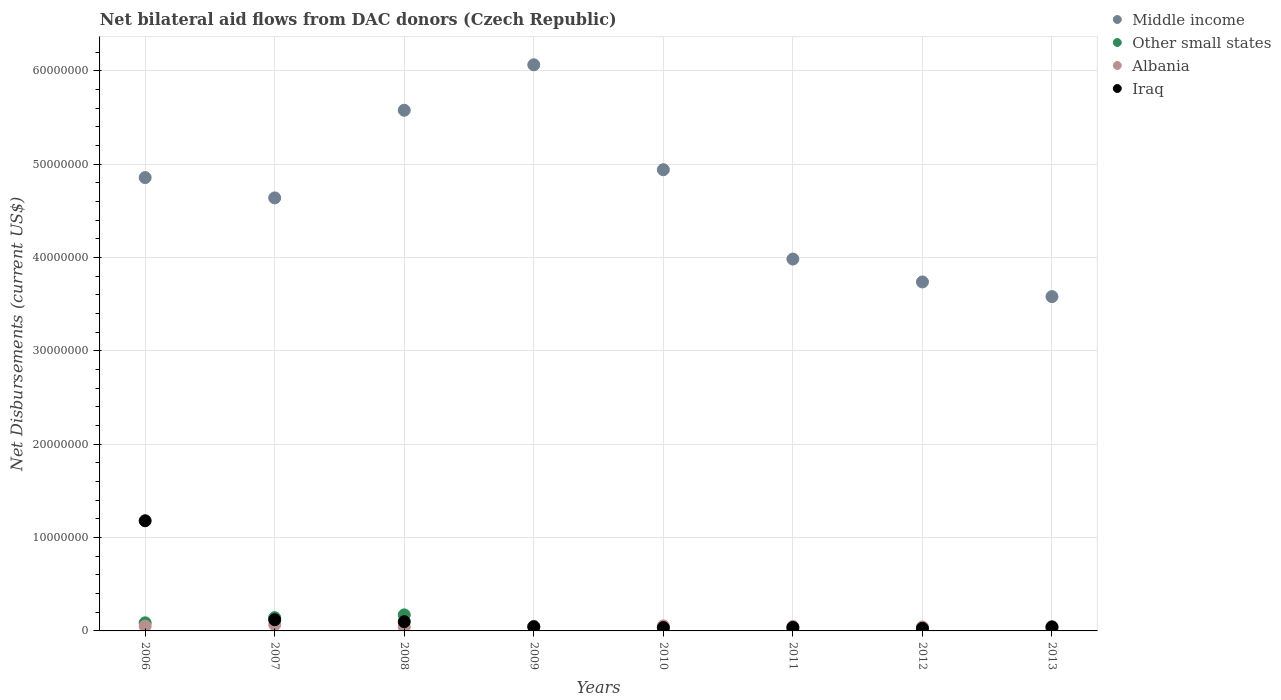How many different coloured dotlines are there?
Give a very brief answer. 4. Is the number of dotlines equal to the number of legend labels?
Give a very brief answer. Yes. What is the net bilateral aid flows in Albania in 2010?
Provide a short and direct response. 5.40e+05. Across all years, what is the maximum net bilateral aid flows in Albania?
Provide a short and direct response. 6.80e+05. Across all years, what is the minimum net bilateral aid flows in Middle income?
Provide a short and direct response. 3.58e+07. What is the total net bilateral aid flows in Albania in the graph?
Give a very brief answer. 3.72e+06. What is the difference between the net bilateral aid flows in Middle income in 2011 and that in 2013?
Your answer should be compact. 4.02e+06. What is the difference between the net bilateral aid flows in Other small states in 2013 and the net bilateral aid flows in Iraq in 2008?
Keep it short and to the point. -6.10e+05. What is the average net bilateral aid flows in Other small states per year?
Offer a very short reply. 7.18e+05. In the year 2006, what is the difference between the net bilateral aid flows in Other small states and net bilateral aid flows in Albania?
Your answer should be compact. 3.60e+05. In how many years, is the net bilateral aid flows in Albania greater than 20000000 US$?
Your answer should be very brief. 0. What is the ratio of the net bilateral aid flows in Albania in 2006 to that in 2011?
Offer a very short reply. 1.09. Is the net bilateral aid flows in Middle income in 2006 less than that in 2008?
Offer a very short reply. Yes. What is the difference between the highest and the second highest net bilateral aid flows in Albania?
Your answer should be very brief. 1.40e+05. What is the difference between the highest and the lowest net bilateral aid flows in Other small states?
Provide a short and direct response. 1.49e+06. Is the net bilateral aid flows in Middle income strictly less than the net bilateral aid flows in Other small states over the years?
Your response must be concise. No. How many years are there in the graph?
Give a very brief answer. 8. What is the difference between two consecutive major ticks on the Y-axis?
Make the answer very short. 1.00e+07. Does the graph contain any zero values?
Your answer should be compact. No. Where does the legend appear in the graph?
Provide a succinct answer. Top right. How are the legend labels stacked?
Offer a terse response. Vertical. What is the title of the graph?
Ensure brevity in your answer.  Net bilateral aid flows from DAC donors (Czech Republic). Does "Vietnam" appear as one of the legend labels in the graph?
Your answer should be very brief. No. What is the label or title of the Y-axis?
Offer a terse response. Net Disbursements (current US$). What is the Net Disbursements (current US$) of Middle income in 2006?
Provide a succinct answer. 4.86e+07. What is the Net Disbursements (current US$) in Other small states in 2006?
Provide a succinct answer. 8.70e+05. What is the Net Disbursements (current US$) of Albania in 2006?
Provide a short and direct response. 5.10e+05. What is the Net Disbursements (current US$) in Iraq in 2006?
Your response must be concise. 1.18e+07. What is the Net Disbursements (current US$) in Middle income in 2007?
Ensure brevity in your answer.  4.64e+07. What is the Net Disbursements (current US$) of Other small states in 2007?
Offer a terse response. 1.42e+06. What is the Net Disbursements (current US$) of Albania in 2007?
Ensure brevity in your answer.  6.80e+05. What is the Net Disbursements (current US$) in Iraq in 2007?
Offer a terse response. 1.20e+06. What is the Net Disbursements (current US$) in Middle income in 2008?
Keep it short and to the point. 5.58e+07. What is the Net Disbursements (current US$) of Other small states in 2008?
Ensure brevity in your answer.  1.72e+06. What is the Net Disbursements (current US$) of Albania in 2008?
Provide a short and direct response. 4.20e+05. What is the Net Disbursements (current US$) of Iraq in 2008?
Your answer should be compact. 9.90e+05. What is the Net Disbursements (current US$) in Middle income in 2009?
Provide a succinct answer. 6.06e+07. What is the Net Disbursements (current US$) in Other small states in 2009?
Offer a terse response. 4.90e+05. What is the Net Disbursements (current US$) in Albania in 2009?
Offer a very short reply. 4.60e+05. What is the Net Disbursements (current US$) of Middle income in 2010?
Ensure brevity in your answer.  4.94e+07. What is the Net Disbursements (current US$) of Other small states in 2010?
Offer a terse response. 3.70e+05. What is the Net Disbursements (current US$) in Albania in 2010?
Your answer should be very brief. 5.40e+05. What is the Net Disbursements (current US$) of Iraq in 2010?
Offer a very short reply. 3.60e+05. What is the Net Disbursements (current US$) of Middle income in 2011?
Your answer should be compact. 3.98e+07. What is the Net Disbursements (current US$) of Other small states in 2011?
Offer a very short reply. 2.30e+05. What is the Net Disbursements (current US$) in Albania in 2011?
Provide a succinct answer. 4.70e+05. What is the Net Disbursements (current US$) of Middle income in 2012?
Give a very brief answer. 3.74e+07. What is the Net Disbursements (current US$) in Other small states in 2012?
Offer a terse response. 2.60e+05. What is the Net Disbursements (current US$) of Albania in 2012?
Provide a succinct answer. 4.20e+05. What is the Net Disbursements (current US$) of Iraq in 2012?
Keep it short and to the point. 2.80e+05. What is the Net Disbursements (current US$) of Middle income in 2013?
Give a very brief answer. 3.58e+07. What is the Net Disbursements (current US$) in Albania in 2013?
Give a very brief answer. 2.20e+05. Across all years, what is the maximum Net Disbursements (current US$) of Middle income?
Keep it short and to the point. 6.06e+07. Across all years, what is the maximum Net Disbursements (current US$) in Other small states?
Make the answer very short. 1.72e+06. Across all years, what is the maximum Net Disbursements (current US$) of Albania?
Make the answer very short. 6.80e+05. Across all years, what is the maximum Net Disbursements (current US$) of Iraq?
Your response must be concise. 1.18e+07. Across all years, what is the minimum Net Disbursements (current US$) of Middle income?
Give a very brief answer. 3.58e+07. What is the total Net Disbursements (current US$) in Middle income in the graph?
Provide a short and direct response. 3.74e+08. What is the total Net Disbursements (current US$) in Other small states in the graph?
Offer a very short reply. 5.74e+06. What is the total Net Disbursements (current US$) in Albania in the graph?
Your answer should be very brief. 3.72e+06. What is the total Net Disbursements (current US$) in Iraq in the graph?
Ensure brevity in your answer.  1.59e+07. What is the difference between the Net Disbursements (current US$) in Middle income in 2006 and that in 2007?
Offer a terse response. 2.18e+06. What is the difference between the Net Disbursements (current US$) in Other small states in 2006 and that in 2007?
Provide a succinct answer. -5.50e+05. What is the difference between the Net Disbursements (current US$) in Iraq in 2006 and that in 2007?
Give a very brief answer. 1.06e+07. What is the difference between the Net Disbursements (current US$) of Middle income in 2006 and that in 2008?
Your response must be concise. -7.21e+06. What is the difference between the Net Disbursements (current US$) in Other small states in 2006 and that in 2008?
Provide a succinct answer. -8.50e+05. What is the difference between the Net Disbursements (current US$) in Iraq in 2006 and that in 2008?
Make the answer very short. 1.08e+07. What is the difference between the Net Disbursements (current US$) of Middle income in 2006 and that in 2009?
Ensure brevity in your answer.  -1.21e+07. What is the difference between the Net Disbursements (current US$) in Albania in 2006 and that in 2009?
Offer a terse response. 5.00e+04. What is the difference between the Net Disbursements (current US$) of Iraq in 2006 and that in 2009?
Provide a succinct answer. 1.14e+07. What is the difference between the Net Disbursements (current US$) of Middle income in 2006 and that in 2010?
Your response must be concise. -8.40e+05. What is the difference between the Net Disbursements (current US$) in Other small states in 2006 and that in 2010?
Keep it short and to the point. 5.00e+05. What is the difference between the Net Disbursements (current US$) of Albania in 2006 and that in 2010?
Offer a very short reply. -3.00e+04. What is the difference between the Net Disbursements (current US$) of Iraq in 2006 and that in 2010?
Provide a short and direct response. 1.14e+07. What is the difference between the Net Disbursements (current US$) of Middle income in 2006 and that in 2011?
Keep it short and to the point. 8.73e+06. What is the difference between the Net Disbursements (current US$) in Other small states in 2006 and that in 2011?
Provide a short and direct response. 6.40e+05. What is the difference between the Net Disbursements (current US$) in Albania in 2006 and that in 2011?
Give a very brief answer. 4.00e+04. What is the difference between the Net Disbursements (current US$) of Iraq in 2006 and that in 2011?
Offer a terse response. 1.14e+07. What is the difference between the Net Disbursements (current US$) in Middle income in 2006 and that in 2012?
Keep it short and to the point. 1.12e+07. What is the difference between the Net Disbursements (current US$) in Albania in 2006 and that in 2012?
Keep it short and to the point. 9.00e+04. What is the difference between the Net Disbursements (current US$) in Iraq in 2006 and that in 2012?
Offer a very short reply. 1.15e+07. What is the difference between the Net Disbursements (current US$) of Middle income in 2006 and that in 2013?
Provide a short and direct response. 1.28e+07. What is the difference between the Net Disbursements (current US$) in Iraq in 2006 and that in 2013?
Offer a terse response. 1.14e+07. What is the difference between the Net Disbursements (current US$) of Middle income in 2007 and that in 2008?
Your response must be concise. -9.39e+06. What is the difference between the Net Disbursements (current US$) of Other small states in 2007 and that in 2008?
Provide a short and direct response. -3.00e+05. What is the difference between the Net Disbursements (current US$) of Middle income in 2007 and that in 2009?
Offer a terse response. -1.43e+07. What is the difference between the Net Disbursements (current US$) of Other small states in 2007 and that in 2009?
Your answer should be very brief. 9.30e+05. What is the difference between the Net Disbursements (current US$) of Albania in 2007 and that in 2009?
Make the answer very short. 2.20e+05. What is the difference between the Net Disbursements (current US$) of Iraq in 2007 and that in 2009?
Ensure brevity in your answer.  7.60e+05. What is the difference between the Net Disbursements (current US$) of Middle income in 2007 and that in 2010?
Your response must be concise. -3.02e+06. What is the difference between the Net Disbursements (current US$) in Other small states in 2007 and that in 2010?
Give a very brief answer. 1.05e+06. What is the difference between the Net Disbursements (current US$) of Albania in 2007 and that in 2010?
Provide a succinct answer. 1.40e+05. What is the difference between the Net Disbursements (current US$) in Iraq in 2007 and that in 2010?
Provide a succinct answer. 8.40e+05. What is the difference between the Net Disbursements (current US$) in Middle income in 2007 and that in 2011?
Keep it short and to the point. 6.55e+06. What is the difference between the Net Disbursements (current US$) of Other small states in 2007 and that in 2011?
Your response must be concise. 1.19e+06. What is the difference between the Net Disbursements (current US$) in Iraq in 2007 and that in 2011?
Give a very brief answer. 8.20e+05. What is the difference between the Net Disbursements (current US$) of Middle income in 2007 and that in 2012?
Your answer should be compact. 9.00e+06. What is the difference between the Net Disbursements (current US$) of Other small states in 2007 and that in 2012?
Make the answer very short. 1.16e+06. What is the difference between the Net Disbursements (current US$) of Iraq in 2007 and that in 2012?
Your answer should be very brief. 9.20e+05. What is the difference between the Net Disbursements (current US$) of Middle income in 2007 and that in 2013?
Offer a very short reply. 1.06e+07. What is the difference between the Net Disbursements (current US$) in Other small states in 2007 and that in 2013?
Ensure brevity in your answer.  1.04e+06. What is the difference between the Net Disbursements (current US$) in Albania in 2007 and that in 2013?
Provide a succinct answer. 4.60e+05. What is the difference between the Net Disbursements (current US$) in Iraq in 2007 and that in 2013?
Offer a terse response. 7.60e+05. What is the difference between the Net Disbursements (current US$) of Middle income in 2008 and that in 2009?
Offer a very short reply. -4.87e+06. What is the difference between the Net Disbursements (current US$) in Other small states in 2008 and that in 2009?
Your answer should be compact. 1.23e+06. What is the difference between the Net Disbursements (current US$) of Iraq in 2008 and that in 2009?
Your answer should be very brief. 5.50e+05. What is the difference between the Net Disbursements (current US$) in Middle income in 2008 and that in 2010?
Provide a succinct answer. 6.37e+06. What is the difference between the Net Disbursements (current US$) of Other small states in 2008 and that in 2010?
Give a very brief answer. 1.35e+06. What is the difference between the Net Disbursements (current US$) in Albania in 2008 and that in 2010?
Offer a terse response. -1.20e+05. What is the difference between the Net Disbursements (current US$) in Iraq in 2008 and that in 2010?
Offer a very short reply. 6.30e+05. What is the difference between the Net Disbursements (current US$) of Middle income in 2008 and that in 2011?
Your answer should be very brief. 1.59e+07. What is the difference between the Net Disbursements (current US$) in Other small states in 2008 and that in 2011?
Your answer should be compact. 1.49e+06. What is the difference between the Net Disbursements (current US$) of Middle income in 2008 and that in 2012?
Offer a terse response. 1.84e+07. What is the difference between the Net Disbursements (current US$) of Other small states in 2008 and that in 2012?
Provide a succinct answer. 1.46e+06. What is the difference between the Net Disbursements (current US$) in Albania in 2008 and that in 2012?
Your response must be concise. 0. What is the difference between the Net Disbursements (current US$) of Iraq in 2008 and that in 2012?
Keep it short and to the point. 7.10e+05. What is the difference between the Net Disbursements (current US$) in Middle income in 2008 and that in 2013?
Provide a succinct answer. 2.00e+07. What is the difference between the Net Disbursements (current US$) of Other small states in 2008 and that in 2013?
Your answer should be compact. 1.34e+06. What is the difference between the Net Disbursements (current US$) in Middle income in 2009 and that in 2010?
Provide a succinct answer. 1.12e+07. What is the difference between the Net Disbursements (current US$) of Other small states in 2009 and that in 2010?
Offer a terse response. 1.20e+05. What is the difference between the Net Disbursements (current US$) of Iraq in 2009 and that in 2010?
Offer a very short reply. 8.00e+04. What is the difference between the Net Disbursements (current US$) of Middle income in 2009 and that in 2011?
Offer a terse response. 2.08e+07. What is the difference between the Net Disbursements (current US$) of Iraq in 2009 and that in 2011?
Make the answer very short. 6.00e+04. What is the difference between the Net Disbursements (current US$) in Middle income in 2009 and that in 2012?
Offer a very short reply. 2.33e+07. What is the difference between the Net Disbursements (current US$) of Other small states in 2009 and that in 2012?
Make the answer very short. 2.30e+05. What is the difference between the Net Disbursements (current US$) of Albania in 2009 and that in 2012?
Give a very brief answer. 4.00e+04. What is the difference between the Net Disbursements (current US$) of Iraq in 2009 and that in 2012?
Provide a succinct answer. 1.60e+05. What is the difference between the Net Disbursements (current US$) of Middle income in 2009 and that in 2013?
Provide a succinct answer. 2.48e+07. What is the difference between the Net Disbursements (current US$) in Albania in 2009 and that in 2013?
Keep it short and to the point. 2.40e+05. What is the difference between the Net Disbursements (current US$) in Middle income in 2010 and that in 2011?
Ensure brevity in your answer.  9.57e+06. What is the difference between the Net Disbursements (current US$) of Albania in 2010 and that in 2011?
Your response must be concise. 7.00e+04. What is the difference between the Net Disbursements (current US$) in Middle income in 2010 and that in 2012?
Your response must be concise. 1.20e+07. What is the difference between the Net Disbursements (current US$) in Albania in 2010 and that in 2012?
Give a very brief answer. 1.20e+05. What is the difference between the Net Disbursements (current US$) of Middle income in 2010 and that in 2013?
Offer a terse response. 1.36e+07. What is the difference between the Net Disbursements (current US$) in Other small states in 2010 and that in 2013?
Make the answer very short. -10000. What is the difference between the Net Disbursements (current US$) of Albania in 2010 and that in 2013?
Your answer should be very brief. 3.20e+05. What is the difference between the Net Disbursements (current US$) in Iraq in 2010 and that in 2013?
Offer a very short reply. -8.00e+04. What is the difference between the Net Disbursements (current US$) in Middle income in 2011 and that in 2012?
Your answer should be very brief. 2.45e+06. What is the difference between the Net Disbursements (current US$) of Albania in 2011 and that in 2012?
Your answer should be compact. 5.00e+04. What is the difference between the Net Disbursements (current US$) in Iraq in 2011 and that in 2012?
Ensure brevity in your answer.  1.00e+05. What is the difference between the Net Disbursements (current US$) of Middle income in 2011 and that in 2013?
Your answer should be very brief. 4.02e+06. What is the difference between the Net Disbursements (current US$) in Albania in 2011 and that in 2013?
Provide a succinct answer. 2.50e+05. What is the difference between the Net Disbursements (current US$) of Middle income in 2012 and that in 2013?
Ensure brevity in your answer.  1.57e+06. What is the difference between the Net Disbursements (current US$) of Other small states in 2012 and that in 2013?
Your response must be concise. -1.20e+05. What is the difference between the Net Disbursements (current US$) in Iraq in 2012 and that in 2013?
Offer a very short reply. -1.60e+05. What is the difference between the Net Disbursements (current US$) of Middle income in 2006 and the Net Disbursements (current US$) of Other small states in 2007?
Make the answer very short. 4.71e+07. What is the difference between the Net Disbursements (current US$) in Middle income in 2006 and the Net Disbursements (current US$) in Albania in 2007?
Make the answer very short. 4.79e+07. What is the difference between the Net Disbursements (current US$) of Middle income in 2006 and the Net Disbursements (current US$) of Iraq in 2007?
Provide a short and direct response. 4.74e+07. What is the difference between the Net Disbursements (current US$) of Other small states in 2006 and the Net Disbursements (current US$) of Albania in 2007?
Your answer should be compact. 1.90e+05. What is the difference between the Net Disbursements (current US$) of Other small states in 2006 and the Net Disbursements (current US$) of Iraq in 2007?
Give a very brief answer. -3.30e+05. What is the difference between the Net Disbursements (current US$) in Albania in 2006 and the Net Disbursements (current US$) in Iraq in 2007?
Keep it short and to the point. -6.90e+05. What is the difference between the Net Disbursements (current US$) of Middle income in 2006 and the Net Disbursements (current US$) of Other small states in 2008?
Give a very brief answer. 4.68e+07. What is the difference between the Net Disbursements (current US$) of Middle income in 2006 and the Net Disbursements (current US$) of Albania in 2008?
Offer a terse response. 4.81e+07. What is the difference between the Net Disbursements (current US$) in Middle income in 2006 and the Net Disbursements (current US$) in Iraq in 2008?
Offer a very short reply. 4.76e+07. What is the difference between the Net Disbursements (current US$) in Other small states in 2006 and the Net Disbursements (current US$) in Albania in 2008?
Your response must be concise. 4.50e+05. What is the difference between the Net Disbursements (current US$) of Other small states in 2006 and the Net Disbursements (current US$) of Iraq in 2008?
Make the answer very short. -1.20e+05. What is the difference between the Net Disbursements (current US$) in Albania in 2006 and the Net Disbursements (current US$) in Iraq in 2008?
Ensure brevity in your answer.  -4.80e+05. What is the difference between the Net Disbursements (current US$) in Middle income in 2006 and the Net Disbursements (current US$) in Other small states in 2009?
Offer a terse response. 4.81e+07. What is the difference between the Net Disbursements (current US$) in Middle income in 2006 and the Net Disbursements (current US$) in Albania in 2009?
Your answer should be compact. 4.81e+07. What is the difference between the Net Disbursements (current US$) of Middle income in 2006 and the Net Disbursements (current US$) of Iraq in 2009?
Offer a very short reply. 4.81e+07. What is the difference between the Net Disbursements (current US$) in Other small states in 2006 and the Net Disbursements (current US$) in Albania in 2009?
Provide a short and direct response. 4.10e+05. What is the difference between the Net Disbursements (current US$) in Middle income in 2006 and the Net Disbursements (current US$) in Other small states in 2010?
Offer a terse response. 4.82e+07. What is the difference between the Net Disbursements (current US$) in Middle income in 2006 and the Net Disbursements (current US$) in Albania in 2010?
Your answer should be compact. 4.80e+07. What is the difference between the Net Disbursements (current US$) in Middle income in 2006 and the Net Disbursements (current US$) in Iraq in 2010?
Offer a very short reply. 4.82e+07. What is the difference between the Net Disbursements (current US$) of Other small states in 2006 and the Net Disbursements (current US$) of Iraq in 2010?
Offer a very short reply. 5.10e+05. What is the difference between the Net Disbursements (current US$) of Albania in 2006 and the Net Disbursements (current US$) of Iraq in 2010?
Your response must be concise. 1.50e+05. What is the difference between the Net Disbursements (current US$) of Middle income in 2006 and the Net Disbursements (current US$) of Other small states in 2011?
Your answer should be very brief. 4.83e+07. What is the difference between the Net Disbursements (current US$) of Middle income in 2006 and the Net Disbursements (current US$) of Albania in 2011?
Give a very brief answer. 4.81e+07. What is the difference between the Net Disbursements (current US$) in Middle income in 2006 and the Net Disbursements (current US$) in Iraq in 2011?
Your answer should be very brief. 4.82e+07. What is the difference between the Net Disbursements (current US$) in Middle income in 2006 and the Net Disbursements (current US$) in Other small states in 2012?
Keep it short and to the point. 4.83e+07. What is the difference between the Net Disbursements (current US$) of Middle income in 2006 and the Net Disbursements (current US$) of Albania in 2012?
Your answer should be compact. 4.81e+07. What is the difference between the Net Disbursements (current US$) in Middle income in 2006 and the Net Disbursements (current US$) in Iraq in 2012?
Offer a very short reply. 4.83e+07. What is the difference between the Net Disbursements (current US$) in Other small states in 2006 and the Net Disbursements (current US$) in Iraq in 2012?
Provide a short and direct response. 5.90e+05. What is the difference between the Net Disbursements (current US$) of Albania in 2006 and the Net Disbursements (current US$) of Iraq in 2012?
Offer a terse response. 2.30e+05. What is the difference between the Net Disbursements (current US$) of Middle income in 2006 and the Net Disbursements (current US$) of Other small states in 2013?
Keep it short and to the point. 4.82e+07. What is the difference between the Net Disbursements (current US$) in Middle income in 2006 and the Net Disbursements (current US$) in Albania in 2013?
Provide a short and direct response. 4.83e+07. What is the difference between the Net Disbursements (current US$) in Middle income in 2006 and the Net Disbursements (current US$) in Iraq in 2013?
Make the answer very short. 4.81e+07. What is the difference between the Net Disbursements (current US$) in Other small states in 2006 and the Net Disbursements (current US$) in Albania in 2013?
Give a very brief answer. 6.50e+05. What is the difference between the Net Disbursements (current US$) in Other small states in 2006 and the Net Disbursements (current US$) in Iraq in 2013?
Your answer should be compact. 4.30e+05. What is the difference between the Net Disbursements (current US$) of Albania in 2006 and the Net Disbursements (current US$) of Iraq in 2013?
Ensure brevity in your answer.  7.00e+04. What is the difference between the Net Disbursements (current US$) of Middle income in 2007 and the Net Disbursements (current US$) of Other small states in 2008?
Offer a very short reply. 4.47e+07. What is the difference between the Net Disbursements (current US$) in Middle income in 2007 and the Net Disbursements (current US$) in Albania in 2008?
Your answer should be compact. 4.60e+07. What is the difference between the Net Disbursements (current US$) in Middle income in 2007 and the Net Disbursements (current US$) in Iraq in 2008?
Ensure brevity in your answer.  4.54e+07. What is the difference between the Net Disbursements (current US$) in Other small states in 2007 and the Net Disbursements (current US$) in Albania in 2008?
Your answer should be compact. 1.00e+06. What is the difference between the Net Disbursements (current US$) of Albania in 2007 and the Net Disbursements (current US$) of Iraq in 2008?
Your answer should be very brief. -3.10e+05. What is the difference between the Net Disbursements (current US$) in Middle income in 2007 and the Net Disbursements (current US$) in Other small states in 2009?
Give a very brief answer. 4.59e+07. What is the difference between the Net Disbursements (current US$) of Middle income in 2007 and the Net Disbursements (current US$) of Albania in 2009?
Give a very brief answer. 4.59e+07. What is the difference between the Net Disbursements (current US$) of Middle income in 2007 and the Net Disbursements (current US$) of Iraq in 2009?
Keep it short and to the point. 4.59e+07. What is the difference between the Net Disbursements (current US$) in Other small states in 2007 and the Net Disbursements (current US$) in Albania in 2009?
Ensure brevity in your answer.  9.60e+05. What is the difference between the Net Disbursements (current US$) of Other small states in 2007 and the Net Disbursements (current US$) of Iraq in 2009?
Your answer should be very brief. 9.80e+05. What is the difference between the Net Disbursements (current US$) of Albania in 2007 and the Net Disbursements (current US$) of Iraq in 2009?
Keep it short and to the point. 2.40e+05. What is the difference between the Net Disbursements (current US$) of Middle income in 2007 and the Net Disbursements (current US$) of Other small states in 2010?
Make the answer very short. 4.60e+07. What is the difference between the Net Disbursements (current US$) in Middle income in 2007 and the Net Disbursements (current US$) in Albania in 2010?
Give a very brief answer. 4.58e+07. What is the difference between the Net Disbursements (current US$) in Middle income in 2007 and the Net Disbursements (current US$) in Iraq in 2010?
Provide a short and direct response. 4.60e+07. What is the difference between the Net Disbursements (current US$) in Other small states in 2007 and the Net Disbursements (current US$) in Albania in 2010?
Offer a very short reply. 8.80e+05. What is the difference between the Net Disbursements (current US$) of Other small states in 2007 and the Net Disbursements (current US$) of Iraq in 2010?
Provide a short and direct response. 1.06e+06. What is the difference between the Net Disbursements (current US$) of Middle income in 2007 and the Net Disbursements (current US$) of Other small states in 2011?
Make the answer very short. 4.62e+07. What is the difference between the Net Disbursements (current US$) in Middle income in 2007 and the Net Disbursements (current US$) in Albania in 2011?
Your response must be concise. 4.59e+07. What is the difference between the Net Disbursements (current US$) in Middle income in 2007 and the Net Disbursements (current US$) in Iraq in 2011?
Keep it short and to the point. 4.60e+07. What is the difference between the Net Disbursements (current US$) of Other small states in 2007 and the Net Disbursements (current US$) of Albania in 2011?
Offer a terse response. 9.50e+05. What is the difference between the Net Disbursements (current US$) in Other small states in 2007 and the Net Disbursements (current US$) in Iraq in 2011?
Make the answer very short. 1.04e+06. What is the difference between the Net Disbursements (current US$) in Albania in 2007 and the Net Disbursements (current US$) in Iraq in 2011?
Your answer should be very brief. 3.00e+05. What is the difference between the Net Disbursements (current US$) in Middle income in 2007 and the Net Disbursements (current US$) in Other small states in 2012?
Keep it short and to the point. 4.61e+07. What is the difference between the Net Disbursements (current US$) of Middle income in 2007 and the Net Disbursements (current US$) of Albania in 2012?
Give a very brief answer. 4.60e+07. What is the difference between the Net Disbursements (current US$) of Middle income in 2007 and the Net Disbursements (current US$) of Iraq in 2012?
Provide a succinct answer. 4.61e+07. What is the difference between the Net Disbursements (current US$) in Other small states in 2007 and the Net Disbursements (current US$) in Iraq in 2012?
Make the answer very short. 1.14e+06. What is the difference between the Net Disbursements (current US$) in Middle income in 2007 and the Net Disbursements (current US$) in Other small states in 2013?
Make the answer very short. 4.60e+07. What is the difference between the Net Disbursements (current US$) in Middle income in 2007 and the Net Disbursements (current US$) in Albania in 2013?
Make the answer very short. 4.62e+07. What is the difference between the Net Disbursements (current US$) in Middle income in 2007 and the Net Disbursements (current US$) in Iraq in 2013?
Provide a succinct answer. 4.59e+07. What is the difference between the Net Disbursements (current US$) in Other small states in 2007 and the Net Disbursements (current US$) in Albania in 2013?
Give a very brief answer. 1.20e+06. What is the difference between the Net Disbursements (current US$) of Other small states in 2007 and the Net Disbursements (current US$) of Iraq in 2013?
Provide a short and direct response. 9.80e+05. What is the difference between the Net Disbursements (current US$) in Albania in 2007 and the Net Disbursements (current US$) in Iraq in 2013?
Give a very brief answer. 2.40e+05. What is the difference between the Net Disbursements (current US$) in Middle income in 2008 and the Net Disbursements (current US$) in Other small states in 2009?
Keep it short and to the point. 5.53e+07. What is the difference between the Net Disbursements (current US$) of Middle income in 2008 and the Net Disbursements (current US$) of Albania in 2009?
Your answer should be very brief. 5.53e+07. What is the difference between the Net Disbursements (current US$) of Middle income in 2008 and the Net Disbursements (current US$) of Iraq in 2009?
Your response must be concise. 5.53e+07. What is the difference between the Net Disbursements (current US$) in Other small states in 2008 and the Net Disbursements (current US$) in Albania in 2009?
Your response must be concise. 1.26e+06. What is the difference between the Net Disbursements (current US$) in Other small states in 2008 and the Net Disbursements (current US$) in Iraq in 2009?
Ensure brevity in your answer.  1.28e+06. What is the difference between the Net Disbursements (current US$) of Albania in 2008 and the Net Disbursements (current US$) of Iraq in 2009?
Your response must be concise. -2.00e+04. What is the difference between the Net Disbursements (current US$) of Middle income in 2008 and the Net Disbursements (current US$) of Other small states in 2010?
Provide a short and direct response. 5.54e+07. What is the difference between the Net Disbursements (current US$) in Middle income in 2008 and the Net Disbursements (current US$) in Albania in 2010?
Offer a very short reply. 5.52e+07. What is the difference between the Net Disbursements (current US$) in Middle income in 2008 and the Net Disbursements (current US$) in Iraq in 2010?
Your answer should be very brief. 5.54e+07. What is the difference between the Net Disbursements (current US$) in Other small states in 2008 and the Net Disbursements (current US$) in Albania in 2010?
Provide a short and direct response. 1.18e+06. What is the difference between the Net Disbursements (current US$) in Other small states in 2008 and the Net Disbursements (current US$) in Iraq in 2010?
Make the answer very short. 1.36e+06. What is the difference between the Net Disbursements (current US$) of Albania in 2008 and the Net Disbursements (current US$) of Iraq in 2010?
Keep it short and to the point. 6.00e+04. What is the difference between the Net Disbursements (current US$) of Middle income in 2008 and the Net Disbursements (current US$) of Other small states in 2011?
Offer a very short reply. 5.55e+07. What is the difference between the Net Disbursements (current US$) of Middle income in 2008 and the Net Disbursements (current US$) of Albania in 2011?
Your answer should be compact. 5.53e+07. What is the difference between the Net Disbursements (current US$) in Middle income in 2008 and the Net Disbursements (current US$) in Iraq in 2011?
Your response must be concise. 5.54e+07. What is the difference between the Net Disbursements (current US$) in Other small states in 2008 and the Net Disbursements (current US$) in Albania in 2011?
Give a very brief answer. 1.25e+06. What is the difference between the Net Disbursements (current US$) in Other small states in 2008 and the Net Disbursements (current US$) in Iraq in 2011?
Offer a very short reply. 1.34e+06. What is the difference between the Net Disbursements (current US$) of Albania in 2008 and the Net Disbursements (current US$) of Iraq in 2011?
Make the answer very short. 4.00e+04. What is the difference between the Net Disbursements (current US$) of Middle income in 2008 and the Net Disbursements (current US$) of Other small states in 2012?
Offer a very short reply. 5.55e+07. What is the difference between the Net Disbursements (current US$) of Middle income in 2008 and the Net Disbursements (current US$) of Albania in 2012?
Give a very brief answer. 5.54e+07. What is the difference between the Net Disbursements (current US$) of Middle income in 2008 and the Net Disbursements (current US$) of Iraq in 2012?
Ensure brevity in your answer.  5.55e+07. What is the difference between the Net Disbursements (current US$) of Other small states in 2008 and the Net Disbursements (current US$) of Albania in 2012?
Offer a very short reply. 1.30e+06. What is the difference between the Net Disbursements (current US$) of Other small states in 2008 and the Net Disbursements (current US$) of Iraq in 2012?
Provide a short and direct response. 1.44e+06. What is the difference between the Net Disbursements (current US$) in Albania in 2008 and the Net Disbursements (current US$) in Iraq in 2012?
Give a very brief answer. 1.40e+05. What is the difference between the Net Disbursements (current US$) in Middle income in 2008 and the Net Disbursements (current US$) in Other small states in 2013?
Offer a terse response. 5.54e+07. What is the difference between the Net Disbursements (current US$) of Middle income in 2008 and the Net Disbursements (current US$) of Albania in 2013?
Your response must be concise. 5.56e+07. What is the difference between the Net Disbursements (current US$) in Middle income in 2008 and the Net Disbursements (current US$) in Iraq in 2013?
Keep it short and to the point. 5.53e+07. What is the difference between the Net Disbursements (current US$) of Other small states in 2008 and the Net Disbursements (current US$) of Albania in 2013?
Provide a short and direct response. 1.50e+06. What is the difference between the Net Disbursements (current US$) of Other small states in 2008 and the Net Disbursements (current US$) of Iraq in 2013?
Your response must be concise. 1.28e+06. What is the difference between the Net Disbursements (current US$) of Albania in 2008 and the Net Disbursements (current US$) of Iraq in 2013?
Make the answer very short. -2.00e+04. What is the difference between the Net Disbursements (current US$) of Middle income in 2009 and the Net Disbursements (current US$) of Other small states in 2010?
Make the answer very short. 6.03e+07. What is the difference between the Net Disbursements (current US$) in Middle income in 2009 and the Net Disbursements (current US$) in Albania in 2010?
Give a very brief answer. 6.01e+07. What is the difference between the Net Disbursements (current US$) in Middle income in 2009 and the Net Disbursements (current US$) in Iraq in 2010?
Offer a very short reply. 6.03e+07. What is the difference between the Net Disbursements (current US$) of Albania in 2009 and the Net Disbursements (current US$) of Iraq in 2010?
Provide a short and direct response. 1.00e+05. What is the difference between the Net Disbursements (current US$) in Middle income in 2009 and the Net Disbursements (current US$) in Other small states in 2011?
Offer a very short reply. 6.04e+07. What is the difference between the Net Disbursements (current US$) in Middle income in 2009 and the Net Disbursements (current US$) in Albania in 2011?
Give a very brief answer. 6.02e+07. What is the difference between the Net Disbursements (current US$) in Middle income in 2009 and the Net Disbursements (current US$) in Iraq in 2011?
Offer a terse response. 6.03e+07. What is the difference between the Net Disbursements (current US$) of Middle income in 2009 and the Net Disbursements (current US$) of Other small states in 2012?
Keep it short and to the point. 6.04e+07. What is the difference between the Net Disbursements (current US$) in Middle income in 2009 and the Net Disbursements (current US$) in Albania in 2012?
Provide a succinct answer. 6.02e+07. What is the difference between the Net Disbursements (current US$) of Middle income in 2009 and the Net Disbursements (current US$) of Iraq in 2012?
Offer a very short reply. 6.04e+07. What is the difference between the Net Disbursements (current US$) in Other small states in 2009 and the Net Disbursements (current US$) in Iraq in 2012?
Give a very brief answer. 2.10e+05. What is the difference between the Net Disbursements (current US$) in Middle income in 2009 and the Net Disbursements (current US$) in Other small states in 2013?
Make the answer very short. 6.03e+07. What is the difference between the Net Disbursements (current US$) in Middle income in 2009 and the Net Disbursements (current US$) in Albania in 2013?
Offer a terse response. 6.04e+07. What is the difference between the Net Disbursements (current US$) of Middle income in 2009 and the Net Disbursements (current US$) of Iraq in 2013?
Give a very brief answer. 6.02e+07. What is the difference between the Net Disbursements (current US$) in Other small states in 2009 and the Net Disbursements (current US$) in Albania in 2013?
Your answer should be compact. 2.70e+05. What is the difference between the Net Disbursements (current US$) of Other small states in 2009 and the Net Disbursements (current US$) of Iraq in 2013?
Offer a very short reply. 5.00e+04. What is the difference between the Net Disbursements (current US$) in Middle income in 2010 and the Net Disbursements (current US$) in Other small states in 2011?
Your response must be concise. 4.92e+07. What is the difference between the Net Disbursements (current US$) of Middle income in 2010 and the Net Disbursements (current US$) of Albania in 2011?
Keep it short and to the point. 4.89e+07. What is the difference between the Net Disbursements (current US$) of Middle income in 2010 and the Net Disbursements (current US$) of Iraq in 2011?
Your answer should be compact. 4.90e+07. What is the difference between the Net Disbursements (current US$) of Middle income in 2010 and the Net Disbursements (current US$) of Other small states in 2012?
Provide a short and direct response. 4.91e+07. What is the difference between the Net Disbursements (current US$) of Middle income in 2010 and the Net Disbursements (current US$) of Albania in 2012?
Make the answer very short. 4.90e+07. What is the difference between the Net Disbursements (current US$) in Middle income in 2010 and the Net Disbursements (current US$) in Iraq in 2012?
Provide a succinct answer. 4.91e+07. What is the difference between the Net Disbursements (current US$) of Other small states in 2010 and the Net Disbursements (current US$) of Iraq in 2012?
Ensure brevity in your answer.  9.00e+04. What is the difference between the Net Disbursements (current US$) of Middle income in 2010 and the Net Disbursements (current US$) of Other small states in 2013?
Provide a short and direct response. 4.90e+07. What is the difference between the Net Disbursements (current US$) of Middle income in 2010 and the Net Disbursements (current US$) of Albania in 2013?
Your answer should be very brief. 4.92e+07. What is the difference between the Net Disbursements (current US$) of Middle income in 2010 and the Net Disbursements (current US$) of Iraq in 2013?
Give a very brief answer. 4.90e+07. What is the difference between the Net Disbursements (current US$) in Other small states in 2010 and the Net Disbursements (current US$) in Albania in 2013?
Offer a very short reply. 1.50e+05. What is the difference between the Net Disbursements (current US$) in Other small states in 2010 and the Net Disbursements (current US$) in Iraq in 2013?
Offer a very short reply. -7.00e+04. What is the difference between the Net Disbursements (current US$) of Middle income in 2011 and the Net Disbursements (current US$) of Other small states in 2012?
Provide a short and direct response. 3.96e+07. What is the difference between the Net Disbursements (current US$) of Middle income in 2011 and the Net Disbursements (current US$) of Albania in 2012?
Make the answer very short. 3.94e+07. What is the difference between the Net Disbursements (current US$) of Middle income in 2011 and the Net Disbursements (current US$) of Iraq in 2012?
Provide a short and direct response. 3.96e+07. What is the difference between the Net Disbursements (current US$) of Middle income in 2011 and the Net Disbursements (current US$) of Other small states in 2013?
Your response must be concise. 3.94e+07. What is the difference between the Net Disbursements (current US$) in Middle income in 2011 and the Net Disbursements (current US$) in Albania in 2013?
Ensure brevity in your answer.  3.96e+07. What is the difference between the Net Disbursements (current US$) in Middle income in 2011 and the Net Disbursements (current US$) in Iraq in 2013?
Keep it short and to the point. 3.94e+07. What is the difference between the Net Disbursements (current US$) of Other small states in 2011 and the Net Disbursements (current US$) of Albania in 2013?
Offer a very short reply. 10000. What is the difference between the Net Disbursements (current US$) of Middle income in 2012 and the Net Disbursements (current US$) of Other small states in 2013?
Your answer should be compact. 3.70e+07. What is the difference between the Net Disbursements (current US$) of Middle income in 2012 and the Net Disbursements (current US$) of Albania in 2013?
Offer a terse response. 3.72e+07. What is the difference between the Net Disbursements (current US$) of Middle income in 2012 and the Net Disbursements (current US$) of Iraq in 2013?
Your response must be concise. 3.69e+07. What is the difference between the Net Disbursements (current US$) in Other small states in 2012 and the Net Disbursements (current US$) in Albania in 2013?
Your response must be concise. 4.00e+04. What is the difference between the Net Disbursements (current US$) of Albania in 2012 and the Net Disbursements (current US$) of Iraq in 2013?
Your answer should be compact. -2.00e+04. What is the average Net Disbursements (current US$) in Middle income per year?
Provide a succinct answer. 4.67e+07. What is the average Net Disbursements (current US$) in Other small states per year?
Your answer should be very brief. 7.18e+05. What is the average Net Disbursements (current US$) of Albania per year?
Give a very brief answer. 4.65e+05. What is the average Net Disbursements (current US$) in Iraq per year?
Offer a terse response. 1.99e+06. In the year 2006, what is the difference between the Net Disbursements (current US$) in Middle income and Net Disbursements (current US$) in Other small states?
Offer a very short reply. 4.77e+07. In the year 2006, what is the difference between the Net Disbursements (current US$) of Middle income and Net Disbursements (current US$) of Albania?
Provide a short and direct response. 4.80e+07. In the year 2006, what is the difference between the Net Disbursements (current US$) in Middle income and Net Disbursements (current US$) in Iraq?
Make the answer very short. 3.68e+07. In the year 2006, what is the difference between the Net Disbursements (current US$) in Other small states and Net Disbursements (current US$) in Albania?
Offer a terse response. 3.60e+05. In the year 2006, what is the difference between the Net Disbursements (current US$) of Other small states and Net Disbursements (current US$) of Iraq?
Offer a terse response. -1.09e+07. In the year 2006, what is the difference between the Net Disbursements (current US$) of Albania and Net Disbursements (current US$) of Iraq?
Your answer should be compact. -1.13e+07. In the year 2007, what is the difference between the Net Disbursements (current US$) of Middle income and Net Disbursements (current US$) of Other small states?
Provide a short and direct response. 4.50e+07. In the year 2007, what is the difference between the Net Disbursements (current US$) of Middle income and Net Disbursements (current US$) of Albania?
Give a very brief answer. 4.57e+07. In the year 2007, what is the difference between the Net Disbursements (current US$) of Middle income and Net Disbursements (current US$) of Iraq?
Offer a very short reply. 4.52e+07. In the year 2007, what is the difference between the Net Disbursements (current US$) in Other small states and Net Disbursements (current US$) in Albania?
Offer a very short reply. 7.40e+05. In the year 2007, what is the difference between the Net Disbursements (current US$) in Albania and Net Disbursements (current US$) in Iraq?
Offer a terse response. -5.20e+05. In the year 2008, what is the difference between the Net Disbursements (current US$) of Middle income and Net Disbursements (current US$) of Other small states?
Ensure brevity in your answer.  5.40e+07. In the year 2008, what is the difference between the Net Disbursements (current US$) in Middle income and Net Disbursements (current US$) in Albania?
Your answer should be compact. 5.54e+07. In the year 2008, what is the difference between the Net Disbursements (current US$) of Middle income and Net Disbursements (current US$) of Iraq?
Your answer should be very brief. 5.48e+07. In the year 2008, what is the difference between the Net Disbursements (current US$) in Other small states and Net Disbursements (current US$) in Albania?
Offer a terse response. 1.30e+06. In the year 2008, what is the difference between the Net Disbursements (current US$) of Other small states and Net Disbursements (current US$) of Iraq?
Keep it short and to the point. 7.30e+05. In the year 2008, what is the difference between the Net Disbursements (current US$) of Albania and Net Disbursements (current US$) of Iraq?
Provide a short and direct response. -5.70e+05. In the year 2009, what is the difference between the Net Disbursements (current US$) in Middle income and Net Disbursements (current US$) in Other small states?
Offer a terse response. 6.02e+07. In the year 2009, what is the difference between the Net Disbursements (current US$) in Middle income and Net Disbursements (current US$) in Albania?
Keep it short and to the point. 6.02e+07. In the year 2009, what is the difference between the Net Disbursements (current US$) in Middle income and Net Disbursements (current US$) in Iraq?
Your answer should be compact. 6.02e+07. In the year 2010, what is the difference between the Net Disbursements (current US$) in Middle income and Net Disbursements (current US$) in Other small states?
Your response must be concise. 4.90e+07. In the year 2010, what is the difference between the Net Disbursements (current US$) of Middle income and Net Disbursements (current US$) of Albania?
Provide a succinct answer. 4.89e+07. In the year 2010, what is the difference between the Net Disbursements (current US$) of Middle income and Net Disbursements (current US$) of Iraq?
Make the answer very short. 4.90e+07. In the year 2010, what is the difference between the Net Disbursements (current US$) in Other small states and Net Disbursements (current US$) in Albania?
Keep it short and to the point. -1.70e+05. In the year 2010, what is the difference between the Net Disbursements (current US$) of Albania and Net Disbursements (current US$) of Iraq?
Offer a very short reply. 1.80e+05. In the year 2011, what is the difference between the Net Disbursements (current US$) of Middle income and Net Disbursements (current US$) of Other small states?
Give a very brief answer. 3.96e+07. In the year 2011, what is the difference between the Net Disbursements (current US$) in Middle income and Net Disbursements (current US$) in Albania?
Your answer should be compact. 3.94e+07. In the year 2011, what is the difference between the Net Disbursements (current US$) in Middle income and Net Disbursements (current US$) in Iraq?
Your answer should be compact. 3.94e+07. In the year 2011, what is the difference between the Net Disbursements (current US$) in Other small states and Net Disbursements (current US$) in Albania?
Offer a terse response. -2.40e+05. In the year 2011, what is the difference between the Net Disbursements (current US$) in Other small states and Net Disbursements (current US$) in Iraq?
Your response must be concise. -1.50e+05. In the year 2011, what is the difference between the Net Disbursements (current US$) in Albania and Net Disbursements (current US$) in Iraq?
Your response must be concise. 9.00e+04. In the year 2012, what is the difference between the Net Disbursements (current US$) of Middle income and Net Disbursements (current US$) of Other small states?
Keep it short and to the point. 3.71e+07. In the year 2012, what is the difference between the Net Disbursements (current US$) in Middle income and Net Disbursements (current US$) in Albania?
Your response must be concise. 3.70e+07. In the year 2012, what is the difference between the Net Disbursements (current US$) in Middle income and Net Disbursements (current US$) in Iraq?
Your answer should be compact. 3.71e+07. In the year 2012, what is the difference between the Net Disbursements (current US$) in Other small states and Net Disbursements (current US$) in Iraq?
Provide a succinct answer. -2.00e+04. In the year 2012, what is the difference between the Net Disbursements (current US$) of Albania and Net Disbursements (current US$) of Iraq?
Your response must be concise. 1.40e+05. In the year 2013, what is the difference between the Net Disbursements (current US$) of Middle income and Net Disbursements (current US$) of Other small states?
Keep it short and to the point. 3.54e+07. In the year 2013, what is the difference between the Net Disbursements (current US$) in Middle income and Net Disbursements (current US$) in Albania?
Offer a terse response. 3.56e+07. In the year 2013, what is the difference between the Net Disbursements (current US$) in Middle income and Net Disbursements (current US$) in Iraq?
Ensure brevity in your answer.  3.54e+07. In the year 2013, what is the difference between the Net Disbursements (current US$) in Other small states and Net Disbursements (current US$) in Albania?
Your answer should be compact. 1.60e+05. In the year 2013, what is the difference between the Net Disbursements (current US$) in Albania and Net Disbursements (current US$) in Iraq?
Provide a succinct answer. -2.20e+05. What is the ratio of the Net Disbursements (current US$) in Middle income in 2006 to that in 2007?
Your answer should be very brief. 1.05. What is the ratio of the Net Disbursements (current US$) in Other small states in 2006 to that in 2007?
Provide a short and direct response. 0.61. What is the ratio of the Net Disbursements (current US$) of Iraq in 2006 to that in 2007?
Provide a short and direct response. 9.83. What is the ratio of the Net Disbursements (current US$) of Middle income in 2006 to that in 2008?
Ensure brevity in your answer.  0.87. What is the ratio of the Net Disbursements (current US$) in Other small states in 2006 to that in 2008?
Provide a short and direct response. 0.51. What is the ratio of the Net Disbursements (current US$) of Albania in 2006 to that in 2008?
Ensure brevity in your answer.  1.21. What is the ratio of the Net Disbursements (current US$) of Iraq in 2006 to that in 2008?
Make the answer very short. 11.92. What is the ratio of the Net Disbursements (current US$) of Middle income in 2006 to that in 2009?
Provide a short and direct response. 0.8. What is the ratio of the Net Disbursements (current US$) in Other small states in 2006 to that in 2009?
Your answer should be compact. 1.78. What is the ratio of the Net Disbursements (current US$) in Albania in 2006 to that in 2009?
Your response must be concise. 1.11. What is the ratio of the Net Disbursements (current US$) in Iraq in 2006 to that in 2009?
Offer a very short reply. 26.82. What is the ratio of the Net Disbursements (current US$) in Other small states in 2006 to that in 2010?
Keep it short and to the point. 2.35. What is the ratio of the Net Disbursements (current US$) of Albania in 2006 to that in 2010?
Provide a succinct answer. 0.94. What is the ratio of the Net Disbursements (current US$) in Iraq in 2006 to that in 2010?
Offer a terse response. 32.78. What is the ratio of the Net Disbursements (current US$) of Middle income in 2006 to that in 2011?
Give a very brief answer. 1.22. What is the ratio of the Net Disbursements (current US$) of Other small states in 2006 to that in 2011?
Make the answer very short. 3.78. What is the ratio of the Net Disbursements (current US$) in Albania in 2006 to that in 2011?
Provide a short and direct response. 1.09. What is the ratio of the Net Disbursements (current US$) in Iraq in 2006 to that in 2011?
Your response must be concise. 31.05. What is the ratio of the Net Disbursements (current US$) of Middle income in 2006 to that in 2012?
Provide a succinct answer. 1.3. What is the ratio of the Net Disbursements (current US$) in Other small states in 2006 to that in 2012?
Give a very brief answer. 3.35. What is the ratio of the Net Disbursements (current US$) in Albania in 2006 to that in 2012?
Your answer should be very brief. 1.21. What is the ratio of the Net Disbursements (current US$) in Iraq in 2006 to that in 2012?
Offer a very short reply. 42.14. What is the ratio of the Net Disbursements (current US$) of Middle income in 2006 to that in 2013?
Offer a terse response. 1.36. What is the ratio of the Net Disbursements (current US$) of Other small states in 2006 to that in 2013?
Your answer should be very brief. 2.29. What is the ratio of the Net Disbursements (current US$) in Albania in 2006 to that in 2013?
Your answer should be compact. 2.32. What is the ratio of the Net Disbursements (current US$) of Iraq in 2006 to that in 2013?
Offer a terse response. 26.82. What is the ratio of the Net Disbursements (current US$) of Middle income in 2007 to that in 2008?
Keep it short and to the point. 0.83. What is the ratio of the Net Disbursements (current US$) in Other small states in 2007 to that in 2008?
Keep it short and to the point. 0.83. What is the ratio of the Net Disbursements (current US$) of Albania in 2007 to that in 2008?
Your answer should be compact. 1.62. What is the ratio of the Net Disbursements (current US$) in Iraq in 2007 to that in 2008?
Ensure brevity in your answer.  1.21. What is the ratio of the Net Disbursements (current US$) of Middle income in 2007 to that in 2009?
Provide a short and direct response. 0.76. What is the ratio of the Net Disbursements (current US$) in Other small states in 2007 to that in 2009?
Your response must be concise. 2.9. What is the ratio of the Net Disbursements (current US$) of Albania in 2007 to that in 2009?
Provide a succinct answer. 1.48. What is the ratio of the Net Disbursements (current US$) of Iraq in 2007 to that in 2009?
Your answer should be very brief. 2.73. What is the ratio of the Net Disbursements (current US$) in Middle income in 2007 to that in 2010?
Your response must be concise. 0.94. What is the ratio of the Net Disbursements (current US$) of Other small states in 2007 to that in 2010?
Give a very brief answer. 3.84. What is the ratio of the Net Disbursements (current US$) of Albania in 2007 to that in 2010?
Your answer should be very brief. 1.26. What is the ratio of the Net Disbursements (current US$) of Iraq in 2007 to that in 2010?
Provide a succinct answer. 3.33. What is the ratio of the Net Disbursements (current US$) of Middle income in 2007 to that in 2011?
Your answer should be compact. 1.16. What is the ratio of the Net Disbursements (current US$) of Other small states in 2007 to that in 2011?
Offer a very short reply. 6.17. What is the ratio of the Net Disbursements (current US$) in Albania in 2007 to that in 2011?
Offer a very short reply. 1.45. What is the ratio of the Net Disbursements (current US$) in Iraq in 2007 to that in 2011?
Keep it short and to the point. 3.16. What is the ratio of the Net Disbursements (current US$) of Middle income in 2007 to that in 2012?
Provide a succinct answer. 1.24. What is the ratio of the Net Disbursements (current US$) of Other small states in 2007 to that in 2012?
Ensure brevity in your answer.  5.46. What is the ratio of the Net Disbursements (current US$) in Albania in 2007 to that in 2012?
Provide a succinct answer. 1.62. What is the ratio of the Net Disbursements (current US$) of Iraq in 2007 to that in 2012?
Your answer should be very brief. 4.29. What is the ratio of the Net Disbursements (current US$) of Middle income in 2007 to that in 2013?
Offer a terse response. 1.3. What is the ratio of the Net Disbursements (current US$) of Other small states in 2007 to that in 2013?
Your response must be concise. 3.74. What is the ratio of the Net Disbursements (current US$) in Albania in 2007 to that in 2013?
Provide a short and direct response. 3.09. What is the ratio of the Net Disbursements (current US$) in Iraq in 2007 to that in 2013?
Provide a succinct answer. 2.73. What is the ratio of the Net Disbursements (current US$) in Middle income in 2008 to that in 2009?
Provide a succinct answer. 0.92. What is the ratio of the Net Disbursements (current US$) of Other small states in 2008 to that in 2009?
Your response must be concise. 3.51. What is the ratio of the Net Disbursements (current US$) of Albania in 2008 to that in 2009?
Offer a very short reply. 0.91. What is the ratio of the Net Disbursements (current US$) of Iraq in 2008 to that in 2009?
Offer a terse response. 2.25. What is the ratio of the Net Disbursements (current US$) in Middle income in 2008 to that in 2010?
Offer a terse response. 1.13. What is the ratio of the Net Disbursements (current US$) of Other small states in 2008 to that in 2010?
Offer a terse response. 4.65. What is the ratio of the Net Disbursements (current US$) of Iraq in 2008 to that in 2010?
Your response must be concise. 2.75. What is the ratio of the Net Disbursements (current US$) of Middle income in 2008 to that in 2011?
Your answer should be very brief. 1.4. What is the ratio of the Net Disbursements (current US$) of Other small states in 2008 to that in 2011?
Provide a succinct answer. 7.48. What is the ratio of the Net Disbursements (current US$) in Albania in 2008 to that in 2011?
Your answer should be compact. 0.89. What is the ratio of the Net Disbursements (current US$) of Iraq in 2008 to that in 2011?
Make the answer very short. 2.61. What is the ratio of the Net Disbursements (current US$) in Middle income in 2008 to that in 2012?
Offer a very short reply. 1.49. What is the ratio of the Net Disbursements (current US$) in Other small states in 2008 to that in 2012?
Provide a short and direct response. 6.62. What is the ratio of the Net Disbursements (current US$) of Albania in 2008 to that in 2012?
Your answer should be very brief. 1. What is the ratio of the Net Disbursements (current US$) of Iraq in 2008 to that in 2012?
Your response must be concise. 3.54. What is the ratio of the Net Disbursements (current US$) of Middle income in 2008 to that in 2013?
Offer a terse response. 1.56. What is the ratio of the Net Disbursements (current US$) in Other small states in 2008 to that in 2013?
Ensure brevity in your answer.  4.53. What is the ratio of the Net Disbursements (current US$) of Albania in 2008 to that in 2013?
Offer a terse response. 1.91. What is the ratio of the Net Disbursements (current US$) in Iraq in 2008 to that in 2013?
Your answer should be compact. 2.25. What is the ratio of the Net Disbursements (current US$) of Middle income in 2009 to that in 2010?
Make the answer very short. 1.23. What is the ratio of the Net Disbursements (current US$) in Other small states in 2009 to that in 2010?
Your answer should be very brief. 1.32. What is the ratio of the Net Disbursements (current US$) in Albania in 2009 to that in 2010?
Keep it short and to the point. 0.85. What is the ratio of the Net Disbursements (current US$) in Iraq in 2009 to that in 2010?
Give a very brief answer. 1.22. What is the ratio of the Net Disbursements (current US$) of Middle income in 2009 to that in 2011?
Make the answer very short. 1.52. What is the ratio of the Net Disbursements (current US$) of Other small states in 2009 to that in 2011?
Provide a short and direct response. 2.13. What is the ratio of the Net Disbursements (current US$) of Albania in 2009 to that in 2011?
Provide a succinct answer. 0.98. What is the ratio of the Net Disbursements (current US$) of Iraq in 2009 to that in 2011?
Your answer should be compact. 1.16. What is the ratio of the Net Disbursements (current US$) in Middle income in 2009 to that in 2012?
Offer a very short reply. 1.62. What is the ratio of the Net Disbursements (current US$) in Other small states in 2009 to that in 2012?
Offer a very short reply. 1.88. What is the ratio of the Net Disbursements (current US$) in Albania in 2009 to that in 2012?
Offer a very short reply. 1.1. What is the ratio of the Net Disbursements (current US$) of Iraq in 2009 to that in 2012?
Your answer should be compact. 1.57. What is the ratio of the Net Disbursements (current US$) of Middle income in 2009 to that in 2013?
Your answer should be compact. 1.69. What is the ratio of the Net Disbursements (current US$) in Other small states in 2009 to that in 2013?
Your response must be concise. 1.29. What is the ratio of the Net Disbursements (current US$) of Albania in 2009 to that in 2013?
Make the answer very short. 2.09. What is the ratio of the Net Disbursements (current US$) in Middle income in 2010 to that in 2011?
Your response must be concise. 1.24. What is the ratio of the Net Disbursements (current US$) in Other small states in 2010 to that in 2011?
Offer a very short reply. 1.61. What is the ratio of the Net Disbursements (current US$) in Albania in 2010 to that in 2011?
Your answer should be compact. 1.15. What is the ratio of the Net Disbursements (current US$) in Iraq in 2010 to that in 2011?
Your answer should be compact. 0.95. What is the ratio of the Net Disbursements (current US$) in Middle income in 2010 to that in 2012?
Provide a succinct answer. 1.32. What is the ratio of the Net Disbursements (current US$) in Other small states in 2010 to that in 2012?
Your answer should be very brief. 1.42. What is the ratio of the Net Disbursements (current US$) of Middle income in 2010 to that in 2013?
Provide a succinct answer. 1.38. What is the ratio of the Net Disbursements (current US$) in Other small states in 2010 to that in 2013?
Keep it short and to the point. 0.97. What is the ratio of the Net Disbursements (current US$) in Albania in 2010 to that in 2013?
Give a very brief answer. 2.45. What is the ratio of the Net Disbursements (current US$) in Iraq in 2010 to that in 2013?
Offer a terse response. 0.82. What is the ratio of the Net Disbursements (current US$) in Middle income in 2011 to that in 2012?
Provide a short and direct response. 1.07. What is the ratio of the Net Disbursements (current US$) of Other small states in 2011 to that in 2012?
Offer a terse response. 0.88. What is the ratio of the Net Disbursements (current US$) of Albania in 2011 to that in 2012?
Provide a succinct answer. 1.12. What is the ratio of the Net Disbursements (current US$) in Iraq in 2011 to that in 2012?
Your answer should be very brief. 1.36. What is the ratio of the Net Disbursements (current US$) of Middle income in 2011 to that in 2013?
Make the answer very short. 1.11. What is the ratio of the Net Disbursements (current US$) in Other small states in 2011 to that in 2013?
Your answer should be compact. 0.61. What is the ratio of the Net Disbursements (current US$) of Albania in 2011 to that in 2013?
Offer a terse response. 2.14. What is the ratio of the Net Disbursements (current US$) of Iraq in 2011 to that in 2013?
Your answer should be compact. 0.86. What is the ratio of the Net Disbursements (current US$) in Middle income in 2012 to that in 2013?
Provide a succinct answer. 1.04. What is the ratio of the Net Disbursements (current US$) of Other small states in 2012 to that in 2013?
Provide a short and direct response. 0.68. What is the ratio of the Net Disbursements (current US$) of Albania in 2012 to that in 2013?
Your answer should be compact. 1.91. What is the ratio of the Net Disbursements (current US$) of Iraq in 2012 to that in 2013?
Your answer should be very brief. 0.64. What is the difference between the highest and the second highest Net Disbursements (current US$) of Middle income?
Your answer should be very brief. 4.87e+06. What is the difference between the highest and the second highest Net Disbursements (current US$) in Iraq?
Make the answer very short. 1.06e+07. What is the difference between the highest and the lowest Net Disbursements (current US$) in Middle income?
Offer a terse response. 2.48e+07. What is the difference between the highest and the lowest Net Disbursements (current US$) of Other small states?
Give a very brief answer. 1.49e+06. What is the difference between the highest and the lowest Net Disbursements (current US$) of Albania?
Provide a succinct answer. 4.60e+05. What is the difference between the highest and the lowest Net Disbursements (current US$) of Iraq?
Provide a short and direct response. 1.15e+07. 